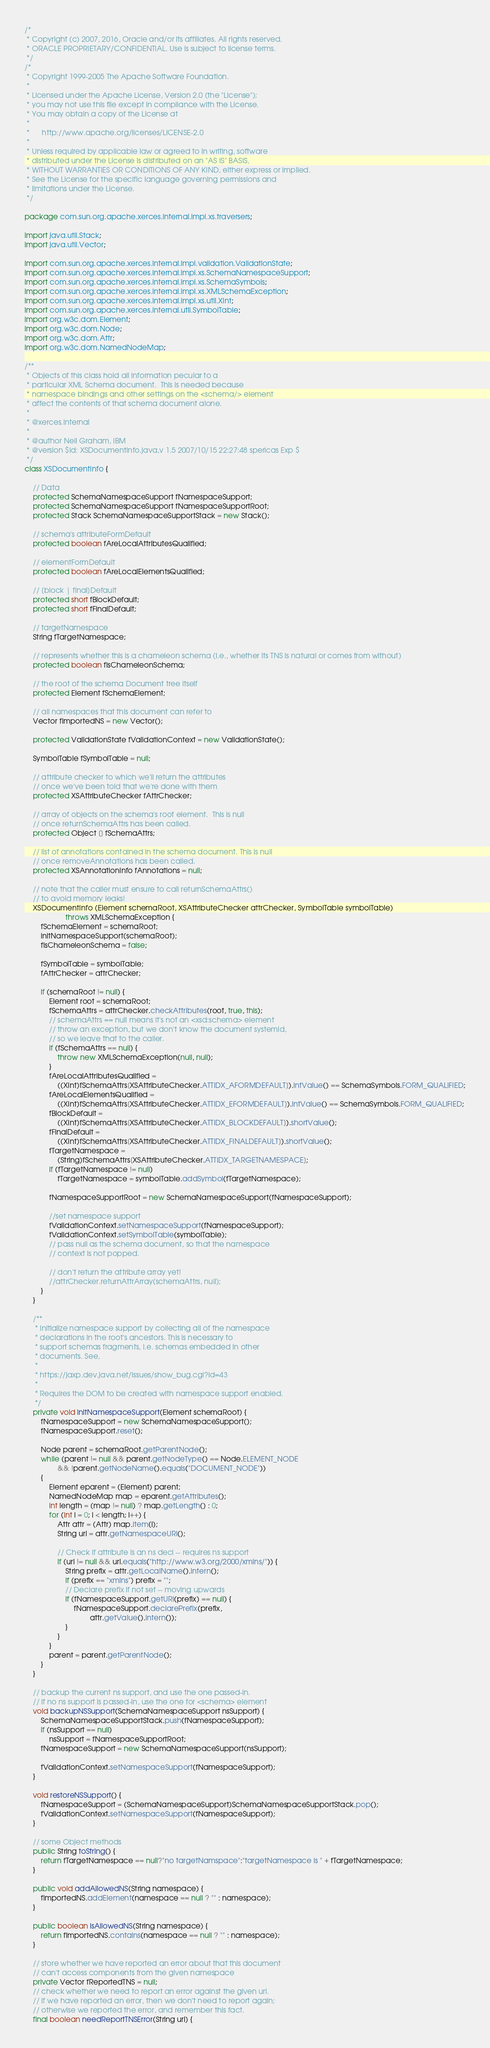<code> <loc_0><loc_0><loc_500><loc_500><_Java_>/*
 * Copyright (c) 2007, 2016, Oracle and/or its affiliates. All rights reserved.
 * ORACLE PROPRIETARY/CONFIDENTIAL. Use is subject to license terms.
 */
/*
 * Copyright 1999-2005 The Apache Software Foundation.
 *
 * Licensed under the Apache License, Version 2.0 (the "License");
 * you may not use this file except in compliance with the License.
 * You may obtain a copy of the License at
 *
 *      http://www.apache.org/licenses/LICENSE-2.0
 *
 * Unless required by applicable law or agreed to in writing, software
 * distributed under the License is distributed on an "AS IS" BASIS,
 * WITHOUT WARRANTIES OR CONDITIONS OF ANY KIND, either express or implied.
 * See the License for the specific language governing permissions and
 * limitations under the License.
 */

package com.sun.org.apache.xerces.internal.impl.xs.traversers;

import java.util.Stack;
import java.util.Vector;

import com.sun.org.apache.xerces.internal.impl.validation.ValidationState;
import com.sun.org.apache.xerces.internal.impl.xs.SchemaNamespaceSupport;
import com.sun.org.apache.xerces.internal.impl.xs.SchemaSymbols;
import com.sun.org.apache.xerces.internal.impl.xs.XMLSchemaException;
import com.sun.org.apache.xerces.internal.impl.xs.util.XInt;
import com.sun.org.apache.xerces.internal.util.SymbolTable;
import org.w3c.dom.Element;
import org.w3c.dom.Node;
import org.w3c.dom.Attr;
import org.w3c.dom.NamedNodeMap;

/**
 * Objects of this class hold all information pecular to a
 * particular XML Schema document.  This is needed because
 * namespace bindings and other settings on the <schema/> element
 * affect the contents of that schema document alone.
 *
 * @xerces.internal
 *
 * @author Neil Graham, IBM
 * @version $Id: XSDocumentInfo.java,v 1.5 2007/10/15 22:27:48 spericas Exp $
 */
class XSDocumentInfo {

    // Data
    protected SchemaNamespaceSupport fNamespaceSupport;
    protected SchemaNamespaceSupport fNamespaceSupportRoot;
    protected Stack SchemaNamespaceSupportStack = new Stack();

    // schema's attributeFormDefault
    protected boolean fAreLocalAttributesQualified;

    // elementFormDefault
    protected boolean fAreLocalElementsQualified;

    // [block | final]Default
    protected short fBlockDefault;
    protected short fFinalDefault;

    // targetNamespace
    String fTargetNamespace;

    // represents whether this is a chameleon schema (i.e., whether its TNS is natural or comes from without)
    protected boolean fIsChameleonSchema;

    // the root of the schema Document tree itself
    protected Element fSchemaElement;

    // all namespaces that this document can refer to
    Vector fImportedNS = new Vector();

    protected ValidationState fValidationContext = new ValidationState();

    SymbolTable fSymbolTable = null;

    // attribute checker to which we'll return the attributes
    // once we've been told that we're done with them
    protected XSAttributeChecker fAttrChecker;

    // array of objects on the schema's root element.  This is null
    // once returnSchemaAttrs has been called.
    protected Object [] fSchemaAttrs;

    // list of annotations contained in the schema document. This is null
    // once removeAnnotations has been called.
    protected XSAnnotationInfo fAnnotations = null;

    // note that the caller must ensure to call returnSchemaAttrs()
    // to avoid memory leaks!
    XSDocumentInfo (Element schemaRoot, XSAttributeChecker attrChecker, SymbolTable symbolTable)
                    throws XMLSchemaException {
        fSchemaElement = schemaRoot;
        initNamespaceSupport(schemaRoot);
        fIsChameleonSchema = false;

        fSymbolTable = symbolTable;
        fAttrChecker = attrChecker;

        if (schemaRoot != null) {
            Element root = schemaRoot;
            fSchemaAttrs = attrChecker.checkAttributes(root, true, this);
            // schemaAttrs == null means it's not an <xsd:schema> element
            // throw an exception, but we don't know the document systemId,
            // so we leave that to the caller.
            if (fSchemaAttrs == null) {
                throw new XMLSchemaException(null, null);
            }
            fAreLocalAttributesQualified =
                ((XInt)fSchemaAttrs[XSAttributeChecker.ATTIDX_AFORMDEFAULT]).intValue() == SchemaSymbols.FORM_QUALIFIED;
            fAreLocalElementsQualified =
                ((XInt)fSchemaAttrs[XSAttributeChecker.ATTIDX_EFORMDEFAULT]).intValue() == SchemaSymbols.FORM_QUALIFIED;
            fBlockDefault =
                ((XInt)fSchemaAttrs[XSAttributeChecker.ATTIDX_BLOCKDEFAULT]).shortValue();
            fFinalDefault =
                ((XInt)fSchemaAttrs[XSAttributeChecker.ATTIDX_FINALDEFAULT]).shortValue();
            fTargetNamespace =
                (String)fSchemaAttrs[XSAttributeChecker.ATTIDX_TARGETNAMESPACE];
            if (fTargetNamespace != null)
                fTargetNamespace = symbolTable.addSymbol(fTargetNamespace);

            fNamespaceSupportRoot = new SchemaNamespaceSupport(fNamespaceSupport);

            //set namespace support
            fValidationContext.setNamespaceSupport(fNamespaceSupport);
            fValidationContext.setSymbolTable(symbolTable);
            // pass null as the schema document, so that the namespace
            // context is not popped.

            // don't return the attribute array yet!
            //attrChecker.returnAttrArray(schemaAttrs, null);
        }
    }

    /**
     * Initialize namespace support by collecting all of the namespace
     * declarations in the root's ancestors. This is necessary to
     * support schemas fragments, i.e. schemas embedded in other
     * documents. See,
     *
     * https://jaxp.dev.java.net/issues/show_bug.cgi?id=43
     *
     * Requires the DOM to be created with namespace support enabled.
     */
    private void initNamespaceSupport(Element schemaRoot) {
        fNamespaceSupport = new SchemaNamespaceSupport();
        fNamespaceSupport.reset();

        Node parent = schemaRoot.getParentNode();
        while (parent != null && parent.getNodeType() == Node.ELEMENT_NODE
                && !parent.getNodeName().equals("DOCUMENT_NODE"))
        {
            Element eparent = (Element) parent;
            NamedNodeMap map = eparent.getAttributes();
            int length = (map != null) ? map.getLength() : 0;
            for (int i = 0; i < length; i++) {
                Attr attr = (Attr) map.item(i);
                String uri = attr.getNamespaceURI();

                // Check if attribute is an ns decl -- requires ns support
                if (uri != null && uri.equals("http://www.w3.org/2000/xmlns/")) {
                    String prefix = attr.getLocalName().intern();
                    if (prefix == "xmlns") prefix = "";
                    // Declare prefix if not set -- moving upwards
                    if (fNamespaceSupport.getURI(prefix) == null) {
                        fNamespaceSupport.declarePrefix(prefix,
                                attr.getValue().intern());
                    }
                }
            }
            parent = parent.getParentNode();
        }
    }

    // backup the current ns support, and use the one passed-in.
    // if no ns support is passed-in, use the one for <schema> element
    void backupNSSupport(SchemaNamespaceSupport nsSupport) {
        SchemaNamespaceSupportStack.push(fNamespaceSupport);
        if (nsSupport == null)
            nsSupport = fNamespaceSupportRoot;
        fNamespaceSupport = new SchemaNamespaceSupport(nsSupport);

        fValidationContext.setNamespaceSupport(fNamespaceSupport);
    }

    void restoreNSSupport() {
        fNamespaceSupport = (SchemaNamespaceSupport)SchemaNamespaceSupportStack.pop();
        fValidationContext.setNamespaceSupport(fNamespaceSupport);
    }

    // some Object methods
    public String toString() {
        return fTargetNamespace == null?"no targetNamspace":"targetNamespace is " + fTargetNamespace;
    }

    public void addAllowedNS(String namespace) {
        fImportedNS.addElement(namespace == null ? "" : namespace);
    }

    public boolean isAllowedNS(String namespace) {
        return fImportedNS.contains(namespace == null ? "" : namespace);
    }

    // store whether we have reported an error about that this document
    // can't access components from the given namespace
    private Vector fReportedTNS = null;
    // check whether we need to report an error against the given uri.
    // if we have reported an error, then we don't need to report again;
    // otherwise we reported the error, and remember this fact.
    final boolean needReportTNSError(String uri) {</code> 